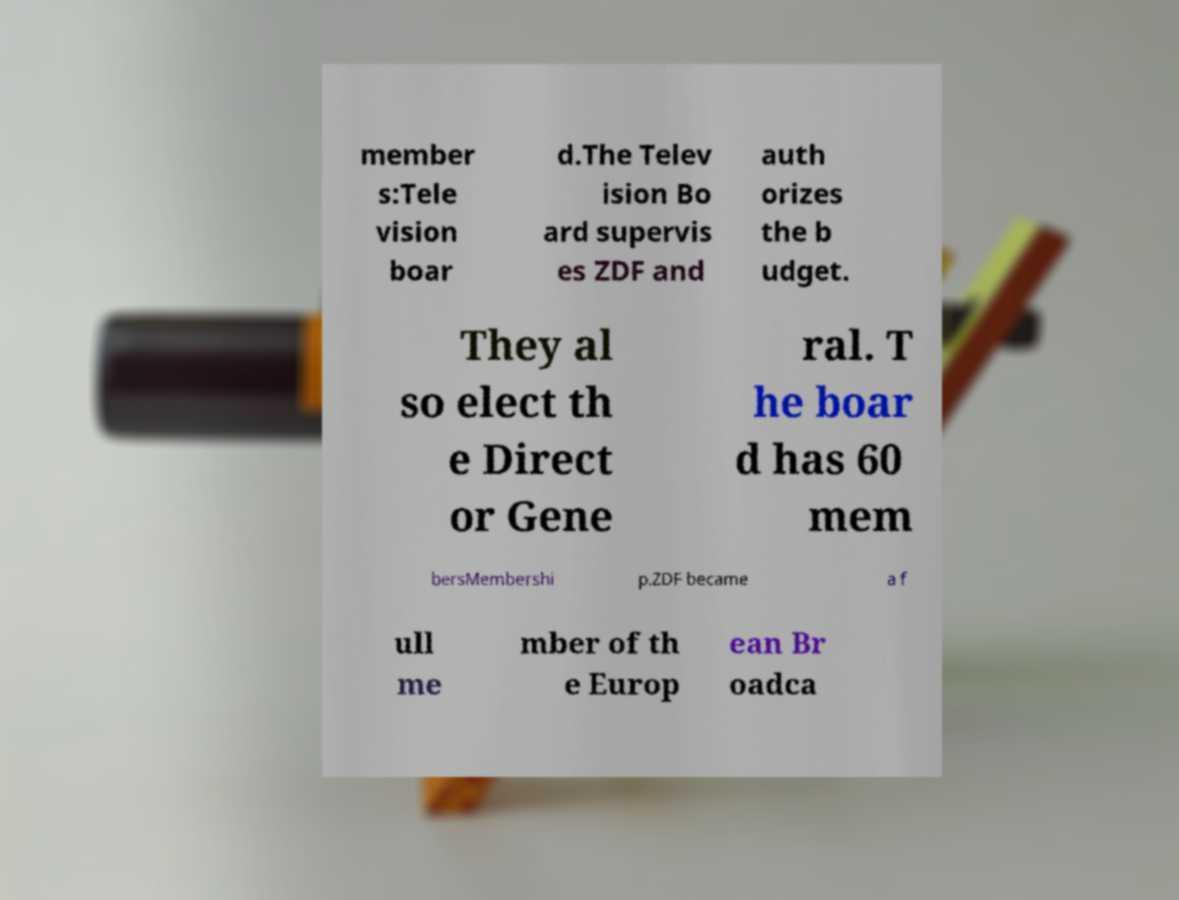I need the written content from this picture converted into text. Can you do that? member s:Tele vision boar d.The Telev ision Bo ard supervis es ZDF and auth orizes the b udget. They al so elect th e Direct or Gene ral. T he boar d has 60 mem bersMembershi p.ZDF became a f ull me mber of th e Europ ean Br oadca 